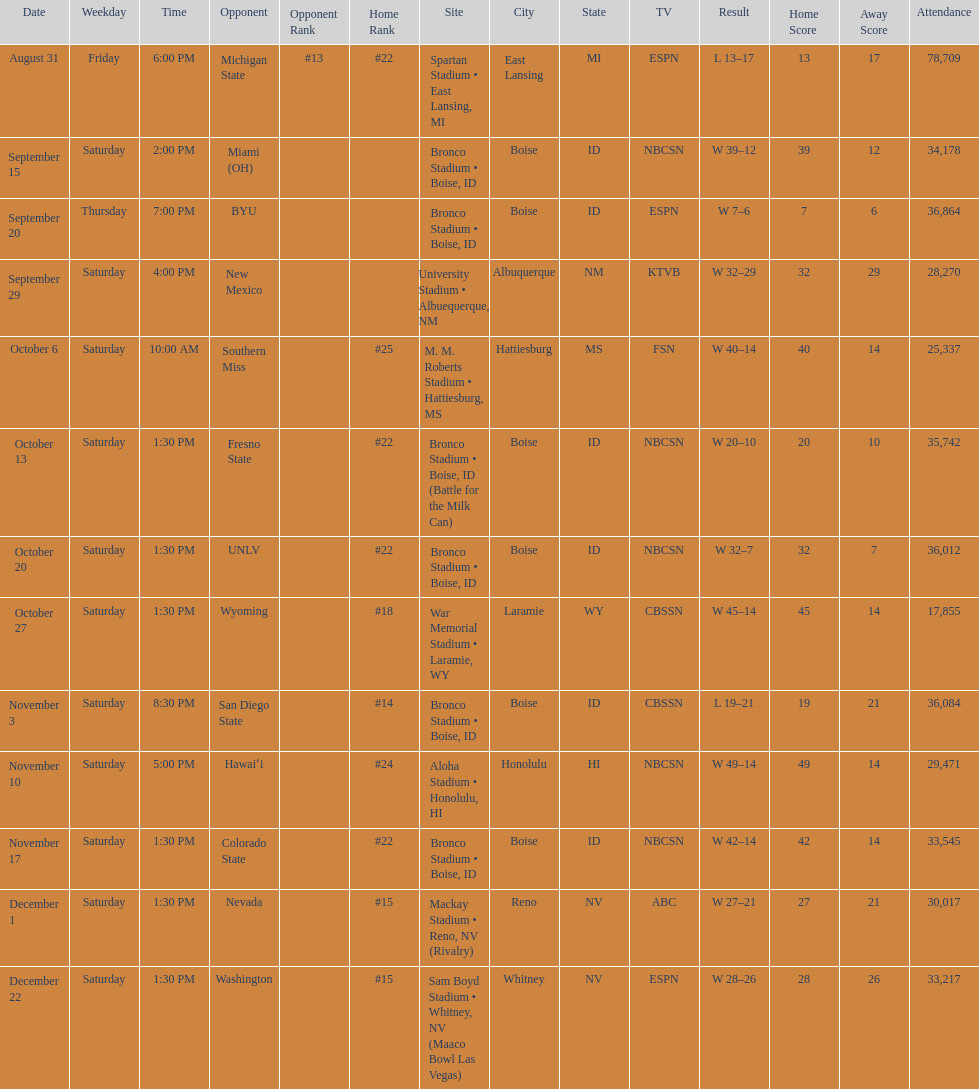Add up the total number of points scored in the last wins for boise state. 146. 